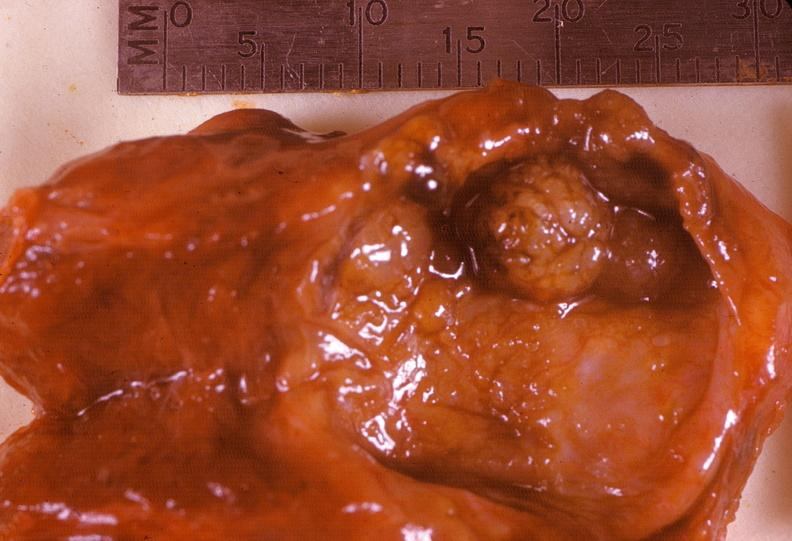s endocrine present?
Answer the question using a single word or phrase. Yes 